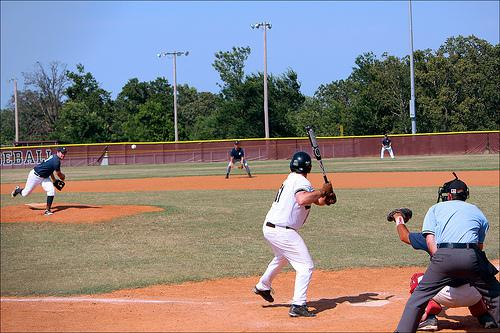Question: what color are the trees?
Choices:
A. Orange.
B. Red.
C. Green and brown.
D. Yellow.
Answer with the letter. Answer: C 